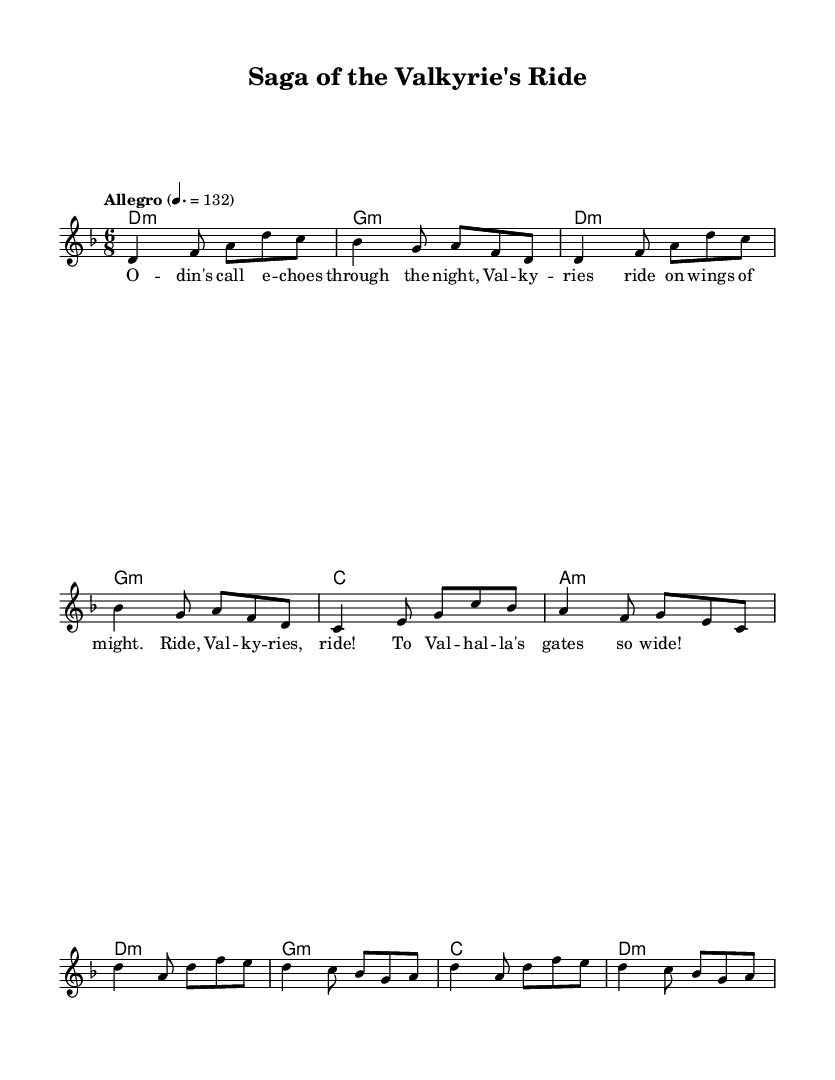What is the key signature of this music? The key signature is indicated at the beginning of the sheet music, showing two flats. This corresponds to the key of D minor.
Answer: D minor What is the time signature of this music? The time signature is found near the beginning of the music, expressed as a fraction showing the beats per measure. Here, it is 6/8, meaning there are six eighth notes per measure.
Answer: 6/8 What is the tempo marking of this music? The tempo marking shows the speed at which the piece should be played. It appears above the staff and states "Allegro," with a metronome marking of 132 beats per minute.
Answer: Allegro 132 How many measures are in the verse section? The verse section can be counted by identifying the measures in the "melody" part labeled as "Verse." There are four measures for the verse.
Answer: 4 What instruments are likely to perform this piece based on its genre? The genre of the music is Viking-inspired folk metal. Typically, this kind of music features electric guitars, drums, and possibly flutes or violins for melodic lines. Thus, it is reasonable to conclude that these instruments would likely perform the piece.
Answer: Electric guitars, drums What is the primary lyrical theme of this composition? The lyrics indicate a focus on Valhalla and Valkyries, which are significant themes in Norse mythology, implying that the song recounts tales of warriors and their journeys.
Answer: Valhalla and Valkyries How many times is the chorus repeated in the score? The chorus is identified in the lyrics section following the verse and is sung twice in succession. Thus, by counting the repetitions, we find it appears two times in the sheet music.
Answer: 2 